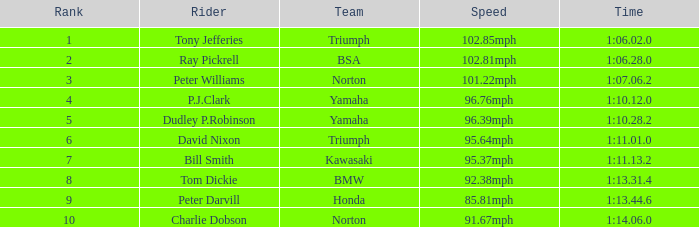76mph pace, what is the time? 1:10.12.0. 